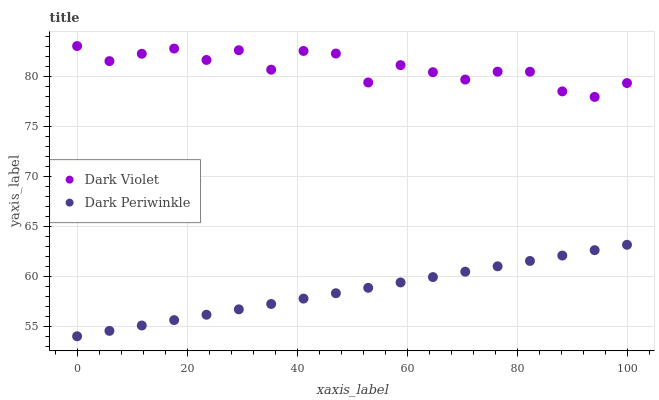Does Dark Periwinkle have the minimum area under the curve?
Answer yes or no. Yes. Does Dark Violet have the maximum area under the curve?
Answer yes or no. Yes. Does Dark Violet have the minimum area under the curve?
Answer yes or no. No. Is Dark Periwinkle the smoothest?
Answer yes or no. Yes. Is Dark Violet the roughest?
Answer yes or no. Yes. Is Dark Violet the smoothest?
Answer yes or no. No. Does Dark Periwinkle have the lowest value?
Answer yes or no. Yes. Does Dark Violet have the lowest value?
Answer yes or no. No. Does Dark Violet have the highest value?
Answer yes or no. Yes. Is Dark Periwinkle less than Dark Violet?
Answer yes or no. Yes. Is Dark Violet greater than Dark Periwinkle?
Answer yes or no. Yes. Does Dark Periwinkle intersect Dark Violet?
Answer yes or no. No. 